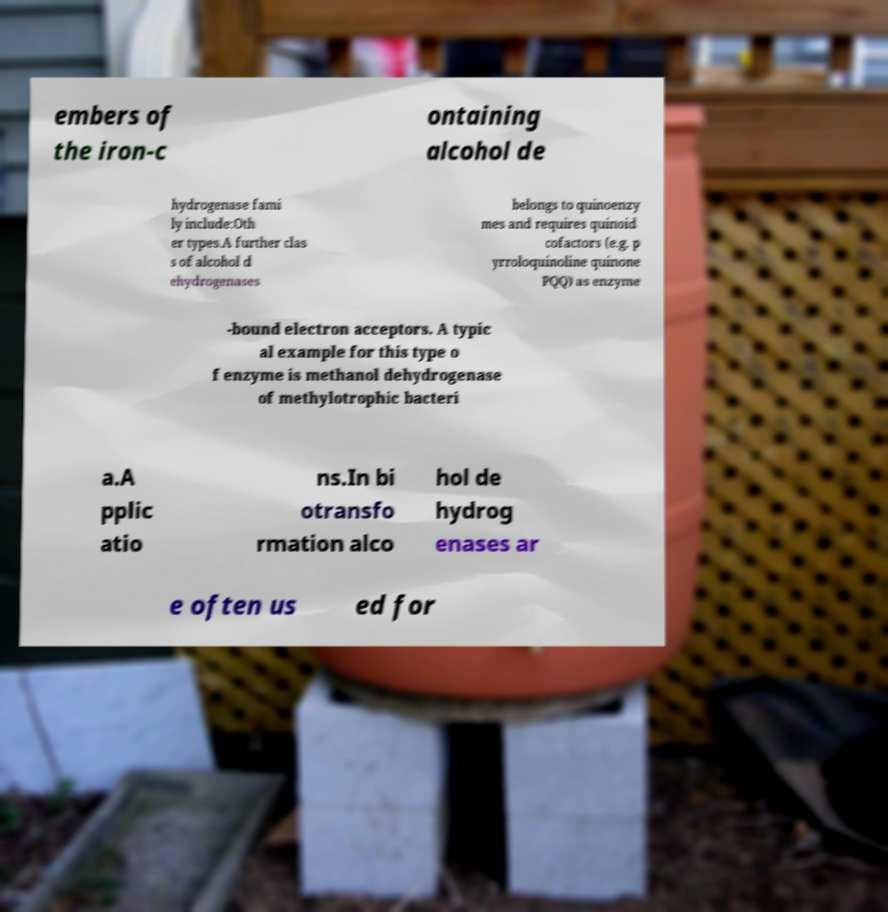Could you extract and type out the text from this image? embers of the iron-c ontaining alcohol de hydrogenase fami ly include:Oth er types.A further clas s of alcohol d ehydrogenases belongs to quinoenzy mes and requires quinoid cofactors (e.g. p yrroloquinoline quinone PQQ) as enzyme -bound electron acceptors. A typic al example for this type o f enzyme is methanol dehydrogenase of methylotrophic bacteri a.A pplic atio ns.In bi otransfo rmation alco hol de hydrog enases ar e often us ed for 